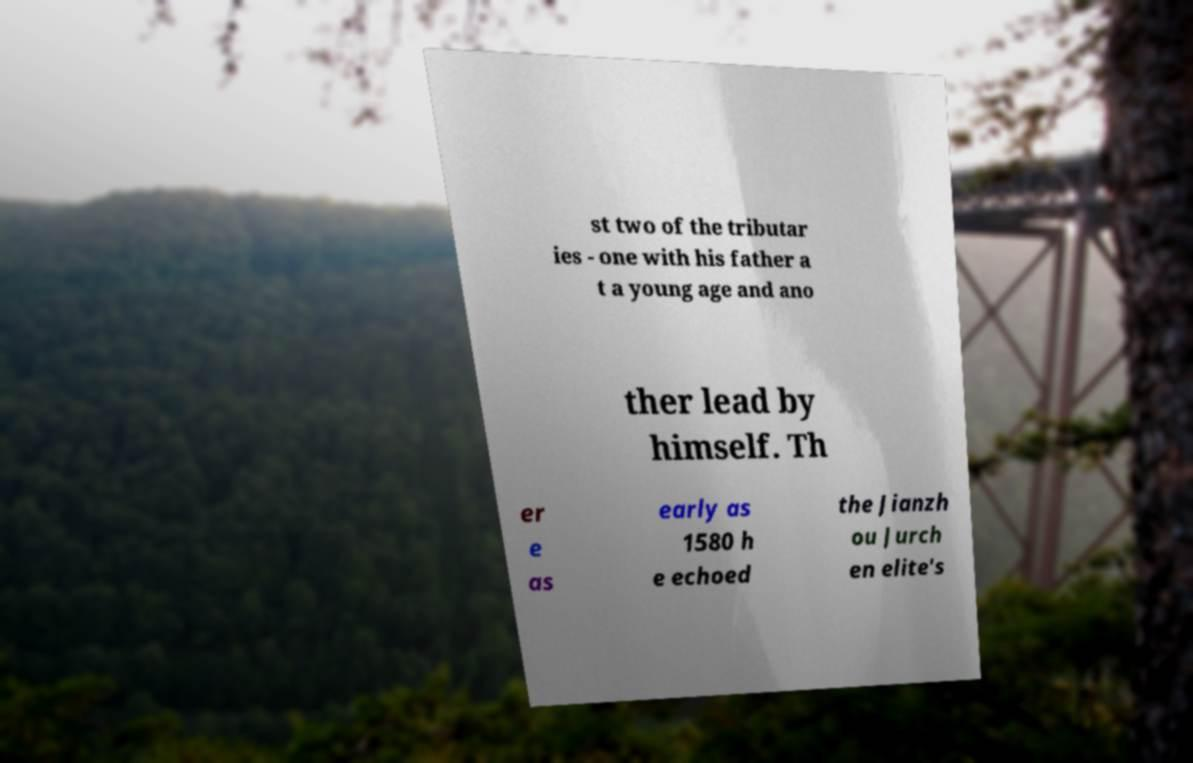Please read and relay the text visible in this image. What does it say? st two of the tributar ies - one with his father a t a young age and ano ther lead by himself. Th er e as early as 1580 h e echoed the Jianzh ou Jurch en elite's 